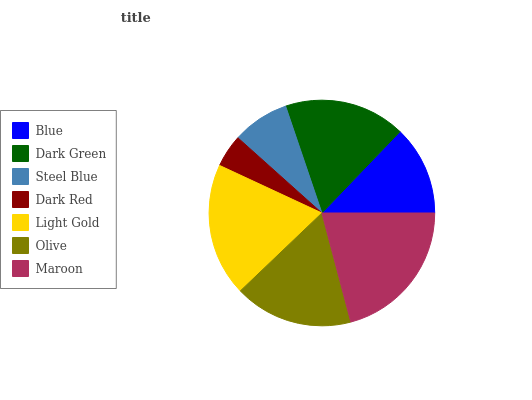Is Dark Red the minimum?
Answer yes or no. Yes. Is Maroon the maximum?
Answer yes or no. Yes. Is Dark Green the minimum?
Answer yes or no. No. Is Dark Green the maximum?
Answer yes or no. No. Is Dark Green greater than Blue?
Answer yes or no. Yes. Is Blue less than Dark Green?
Answer yes or no. Yes. Is Blue greater than Dark Green?
Answer yes or no. No. Is Dark Green less than Blue?
Answer yes or no. No. Is Olive the high median?
Answer yes or no. Yes. Is Olive the low median?
Answer yes or no. Yes. Is Dark Red the high median?
Answer yes or no. No. Is Steel Blue the low median?
Answer yes or no. No. 